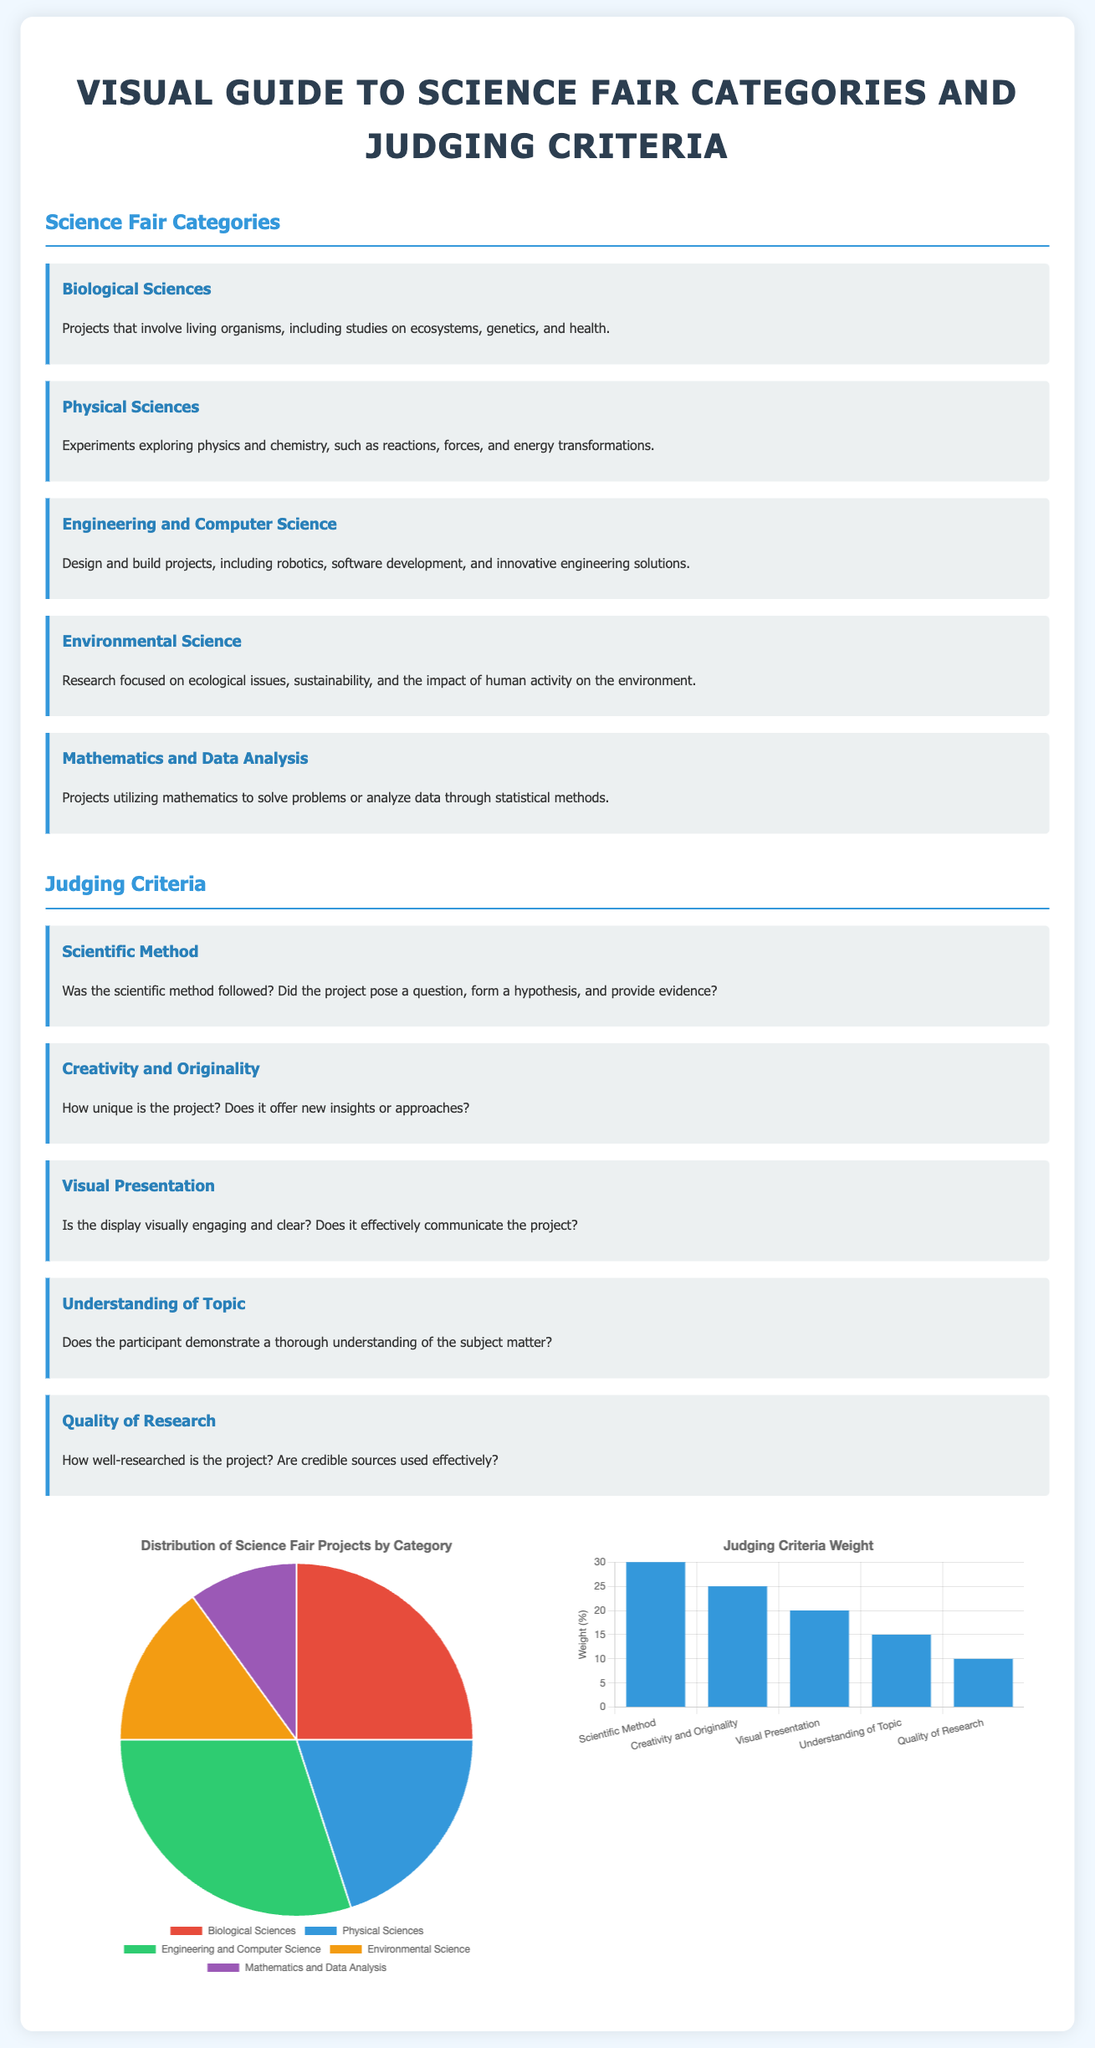What are the categories of science fair projects? The categories of science fair projects are listed under "Science Fair Categories," including Biological Sciences, Physical Sciences, Engineering and Computer Science, Environmental Science, and Mathematics and Data Analysis.
Answer: Biological Sciences, Physical Sciences, Engineering and Computer Science, Environmental Science, Mathematics and Data Analysis What is the weight of the Scientific Method in judging? The weight of the Scientific Method is specified in the "Judging Criteria Weight" chart, indicating its importance in the evaluation process.
Answer: 30 Which category has the highest percentage of projects? The "Distribution of Science Fair Projects by Category" pie chart shows the percentage of projects per category, identifying the one with the most representation.
Answer: Engineering and Computer Science What is the focus of Environmental Science projects? The description under the Environmental Science category explains the primary focus of projects in this area.
Answer: Ecological issues, sustainability, and impact of human activity How many criteria are there for judging science projects? The "Judging Criteria" section outlines the criteria that need to be evaluated for the projects, counting the total number listed.
Answer: 5 What does Visual Presentation assess in judging criteria? The criteria for Visual Presentation detail what is evaluated regarding the display of a project.
Answer: Is the display visually engaging and clear? What type of chart is used to represent project distribution? The document details the type of chart used for visualizing project distribution by category.
Answer: Pie What is the primary purpose of the infographics in the document? The infographics in the document serve to visually summarize important information related to project categories and judging criteria.
Answer: Visual summary 